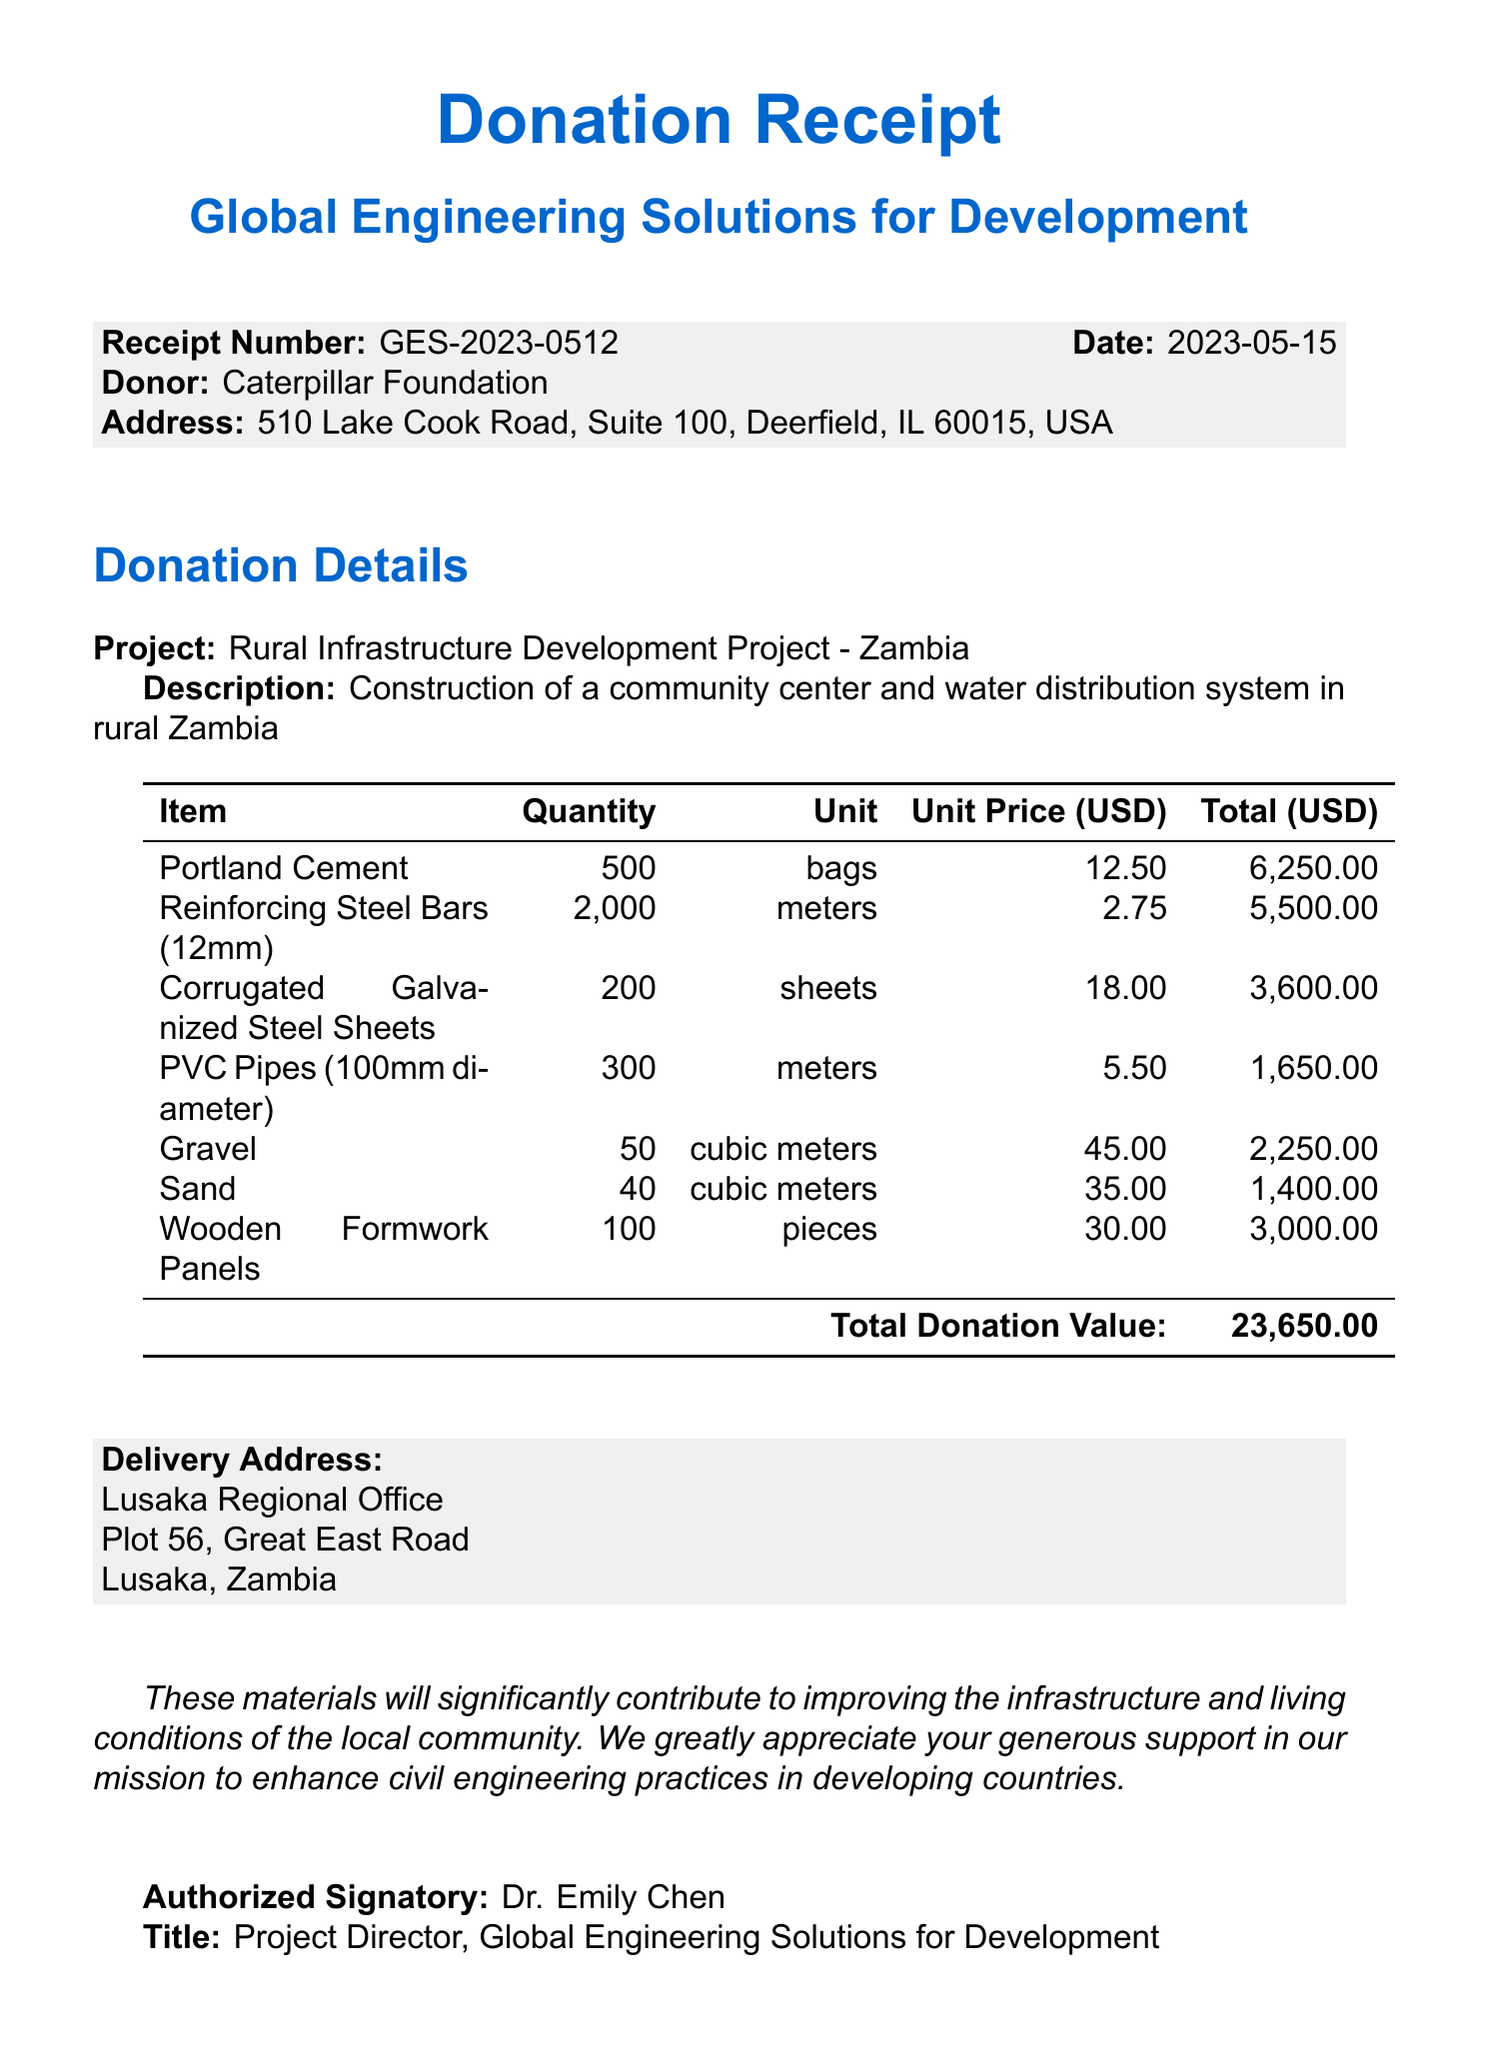What is the name of the donor? The document explicitly states the name of the donor as "Caterpillar Foundation."
Answer: Caterpillar Foundation What is the total donation value? The total value of the donation is clearly mentioned in the document as $23650.00.
Answer: 23650.00 When was the donation made? The date of the donation is listed as 2023-05-15 in the receipt.
Answer: 2023-05-15 What is the address of the donor? The donor's address includes "510 Lake Cook Road, Suite 100, Deerfield, IL 60015, USA."
Answer: 510 Lake Cook Road, Suite 100, Deerfield, IL 60015, USA Who is the authorized signatory? The document identifies the authorized signatory as "Dr. Emily Chen."
Answer: Dr. Emily Chen How many bags of Portland Cement were donated? In the itemized list, there are 500 bags of Portland Cement listed as part of the donation.
Answer: 500 bags What is the quantity of Reinforcing Steel Bars donated? The itemized section indicates that 2000 meters of Reinforcing Steel Bars (12mm) were part of the donation.
Answer: 2000 meters What is the purpose of the project funded by this donation? The description of the project states it is for "Construction of a community center and water distribution system in rural Zambia."
Answer: Construction of a community center and water distribution system in rural Zambia What may vary regarding the donation's tax status? The document notes that "This donation may be tax-deductible," indicating variability based on individual circumstances.
Answer: May be tax-deductible 